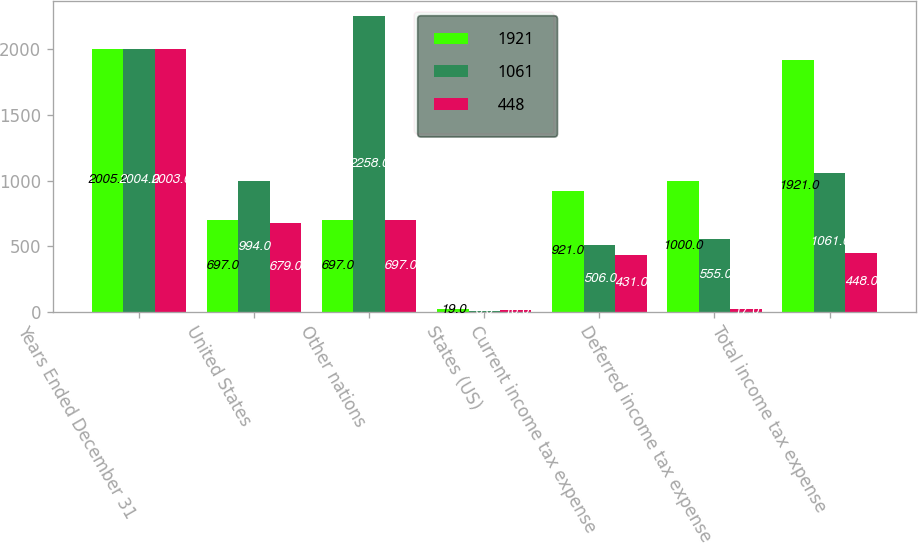Convert chart. <chart><loc_0><loc_0><loc_500><loc_500><stacked_bar_chart><ecel><fcel>Years Ended December 31<fcel>United States<fcel>Other nations<fcel>States (US)<fcel>Current income tax expense<fcel>Deferred income tax expense<fcel>Total income tax expense<nl><fcel>1921<fcel>2005<fcel>697<fcel>697<fcel>19<fcel>921<fcel>1000<fcel>1921<nl><fcel>1061<fcel>2004<fcel>994<fcel>2258<fcel>6<fcel>506<fcel>555<fcel>1061<nl><fcel>448<fcel>2003<fcel>679<fcel>697<fcel>16<fcel>431<fcel>17<fcel>448<nl></chart> 